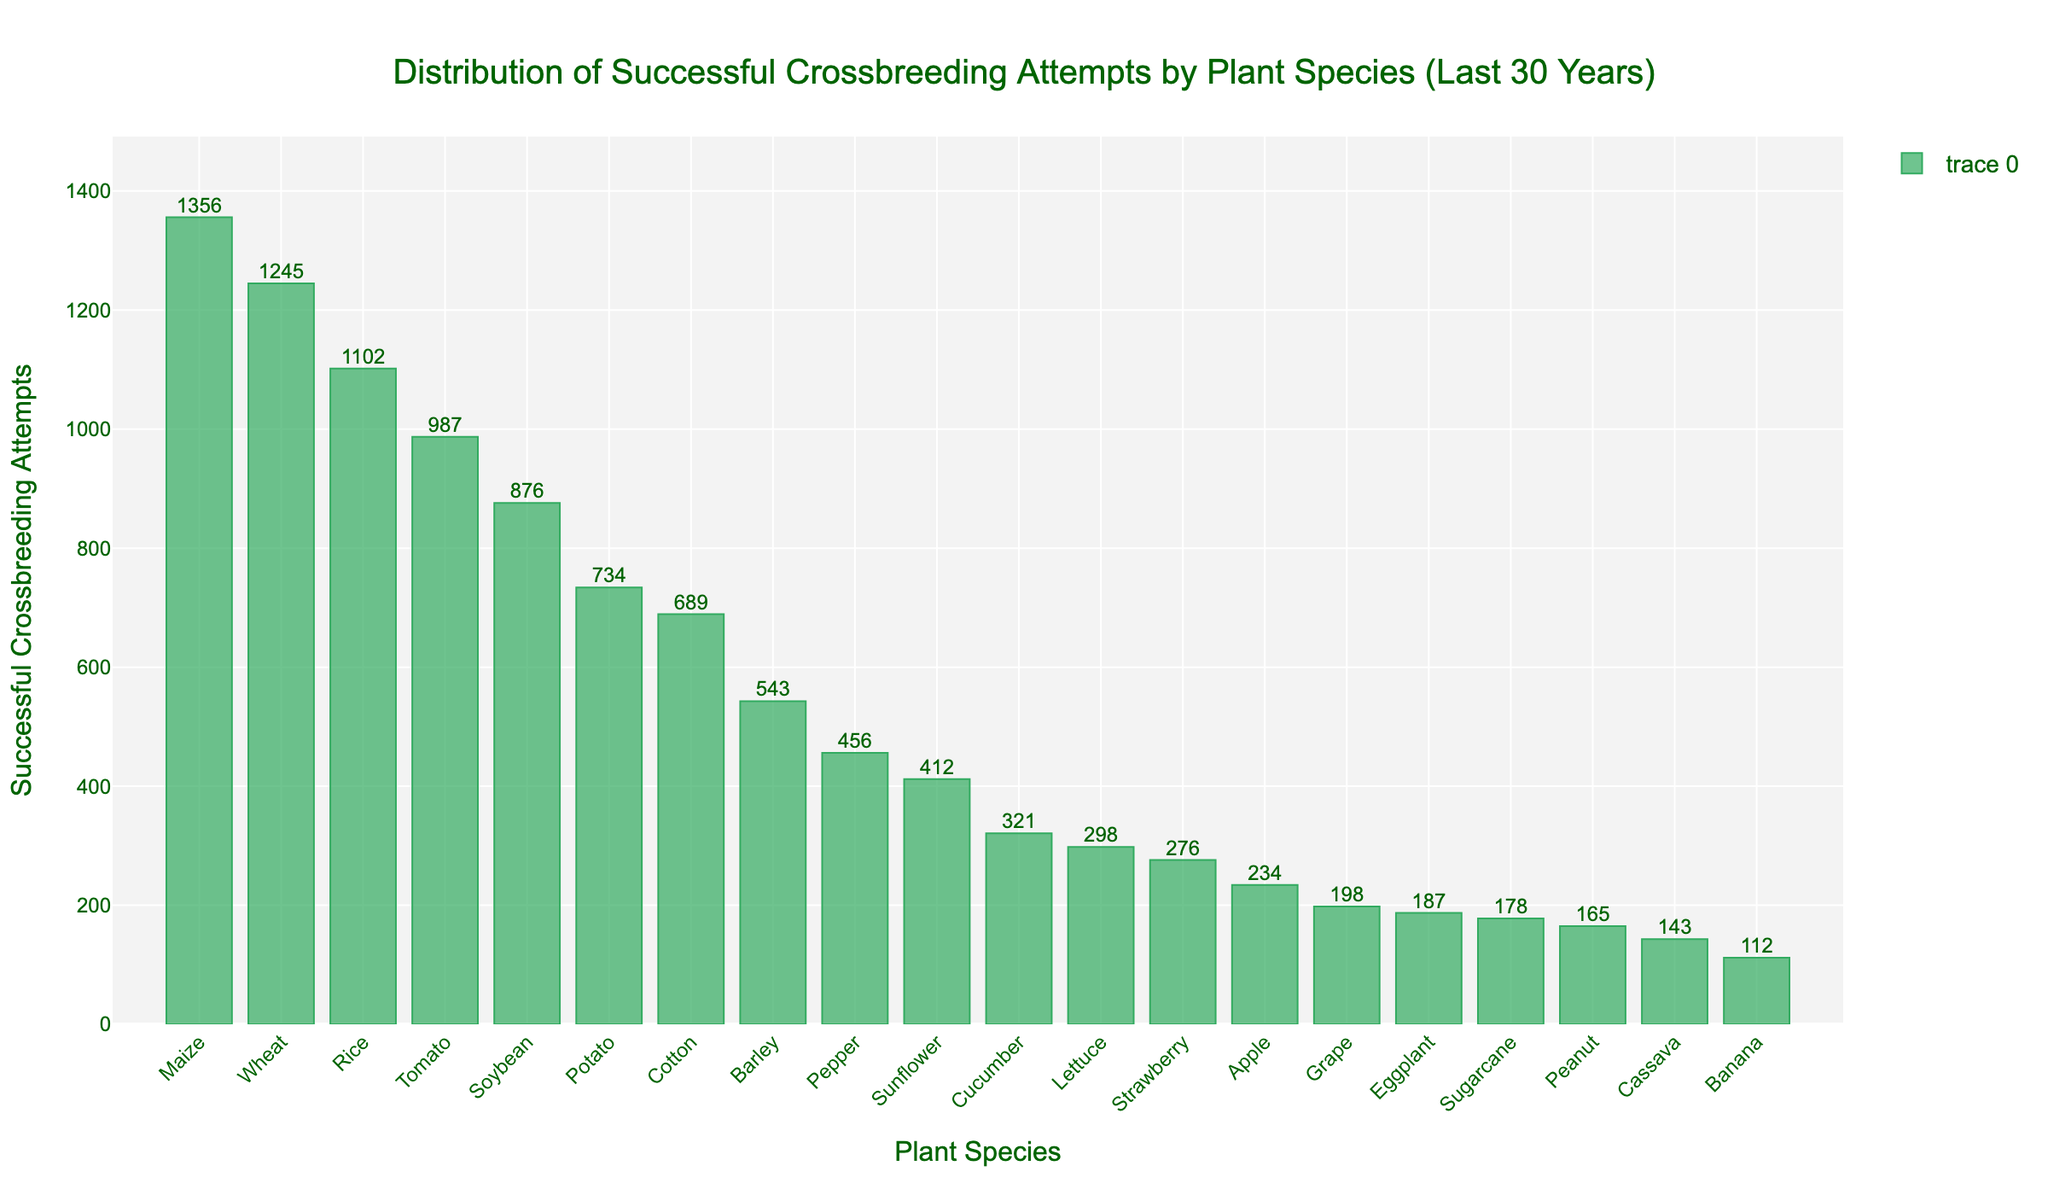Which plant species had the highest number of successful crossbreeding attempts? The tallest bar in the bar chart helps identify the plant species with the highest number of successful crossbreeding attempts. The tallest bar corresponds to Maize with 1356 attempts.
Answer: Maize Which plant species had the lowest number of successful crossbreeding attempts? The shortest bar in the bar chart helps identify the plant species with the lowest number of successful crossbreeding attempts. The shortest bar corresponds to Banana with 112 attempts.
Answer: Banana How many successful crossbreeding attempts were made for Wheat and Rice combined? To find the combined number of successful crossbreeding attempts for Wheat and Rice, add their individual attempts. Wheat had 1245 attempts and Rice had 1102 attempts. So, 1245 + 1102 = 2347.
Answer: 2347 Which plant species had more successful crossbreeding attempts, Tomato or Cotton? Comparing the heights of the bars for Tomato and Cotton helps determine which had more successful crossbreeding attempts. Tomato had 987 attempts, while Cotton had 689 attempts, so Tomato had more.
Answer: Tomato What is the total number of successful crossbreeding attempts for all plant species? Adding the successful crossbreeding attempts for all plant species gives the total. Sum of attempts: Wheat (1245) + Tomato (987) + Rice (1102) + Maize (1356) + Soybean (876) + Potato (734) + Barley (543) + Cotton (689) + Sunflower (412) + Lettuce (298) + Pepper (456) + Cucumber (321) + Eggplant (187) + Strawberry (276) + Grape (198) + Apple (234) + Peanut (165) + Cassava (143) + Sugarcane (178) + Banana (112) = 11502.
Answer: 11502 What is the difference in the number of successful crossbreeding attempts between Maize and Pepper? Subtract the number of successful crossbreeding attempts of Pepper from Maize. Maize had 1356 attempts and Pepper had 456, so the difference is 1356 - 456 = 900.
Answer: 900 Which plant species had a greater number of successful crossbreeding attempts: Peanut or Sugarcane? Comparing the heights of the bars for Peanut and Sugarcane helps determine which had more successful crossbreeding attempts. Peanut had 165 attempts, while Sugarcane had 178 attempts, so Sugarcane had more.
Answer: Sugarcane What is the average number of successful crossbreeding attempts per plant species? To find the average, divide the total number of attempts by the number of plant species. There are 20 species, and the total number of attempts is 11502. So, 11502 / 20 = 575.1.
Answer: 575.1 What is the median number of successful crossbreeding attempts among all plant species? To find the median, list the number of attempts in ascending order and find the middle value. The sorted attempts are [112, 143, 165, 178, 187, 198, 234, 276, 298, 321, 412, 456, 543, 689, 734, 876, 987, 1102, 1245, 1356]. With 20 numbers, the median is the average of the 10th and 11th values: (321 + 412) / 2 = 366.5.
Answer: 366.5 Which plant species cluster around 400 to 500 successful crossbreeding attempts? Check the bars that have their values in the range of 400 to 500 attempts. Sunflower has 412 attempts and Pepper has 456 attempts.
Answer: Sunflower, Pepper 